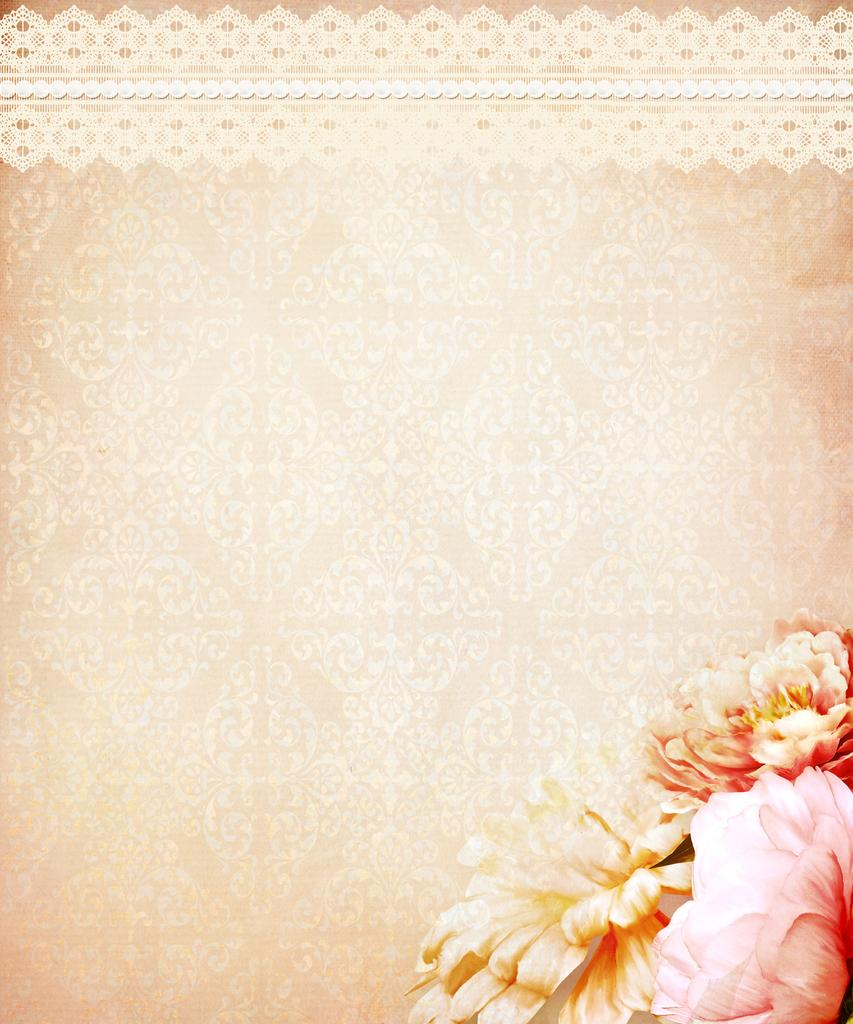What type of design is featured on the wall in the image? There is a wallpaper in the image. Are there any specific elements or patterns on the wallpaper? Flowers are present in the bottom right corner of the image. What type of cap is the sun wearing in the image? There is no sun or cap present in the image. The image only features a wallpaper with flowers in the bottom right corner. 